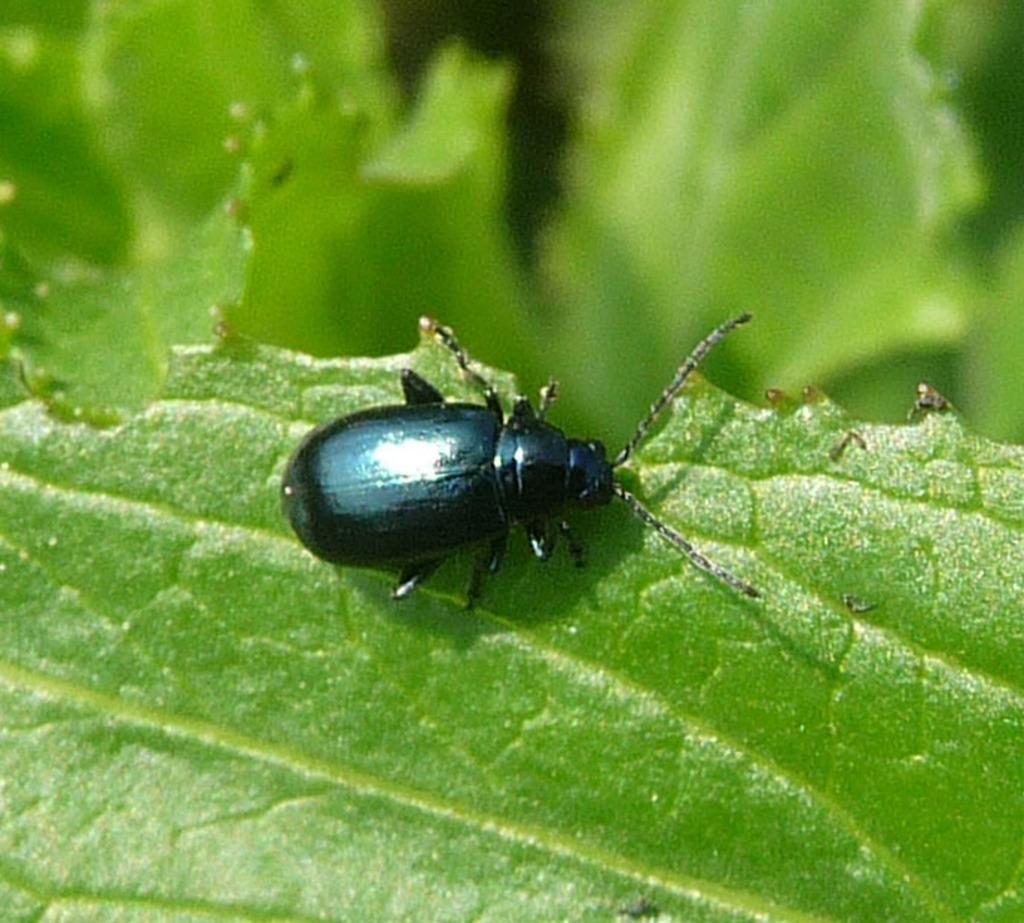What type of creature is in the image? There is an insect in the image. What color is the insect? The insect is black in color. Where is the insect located? The insect is on a leaf. What color is the leaf? The leaf is green in color. How would you describe the background of the image? The background of the image is blurred. Can you tell me when the insect was born in the image? The image does not provide information about the insect's birth, so it cannot be determined from the image. 